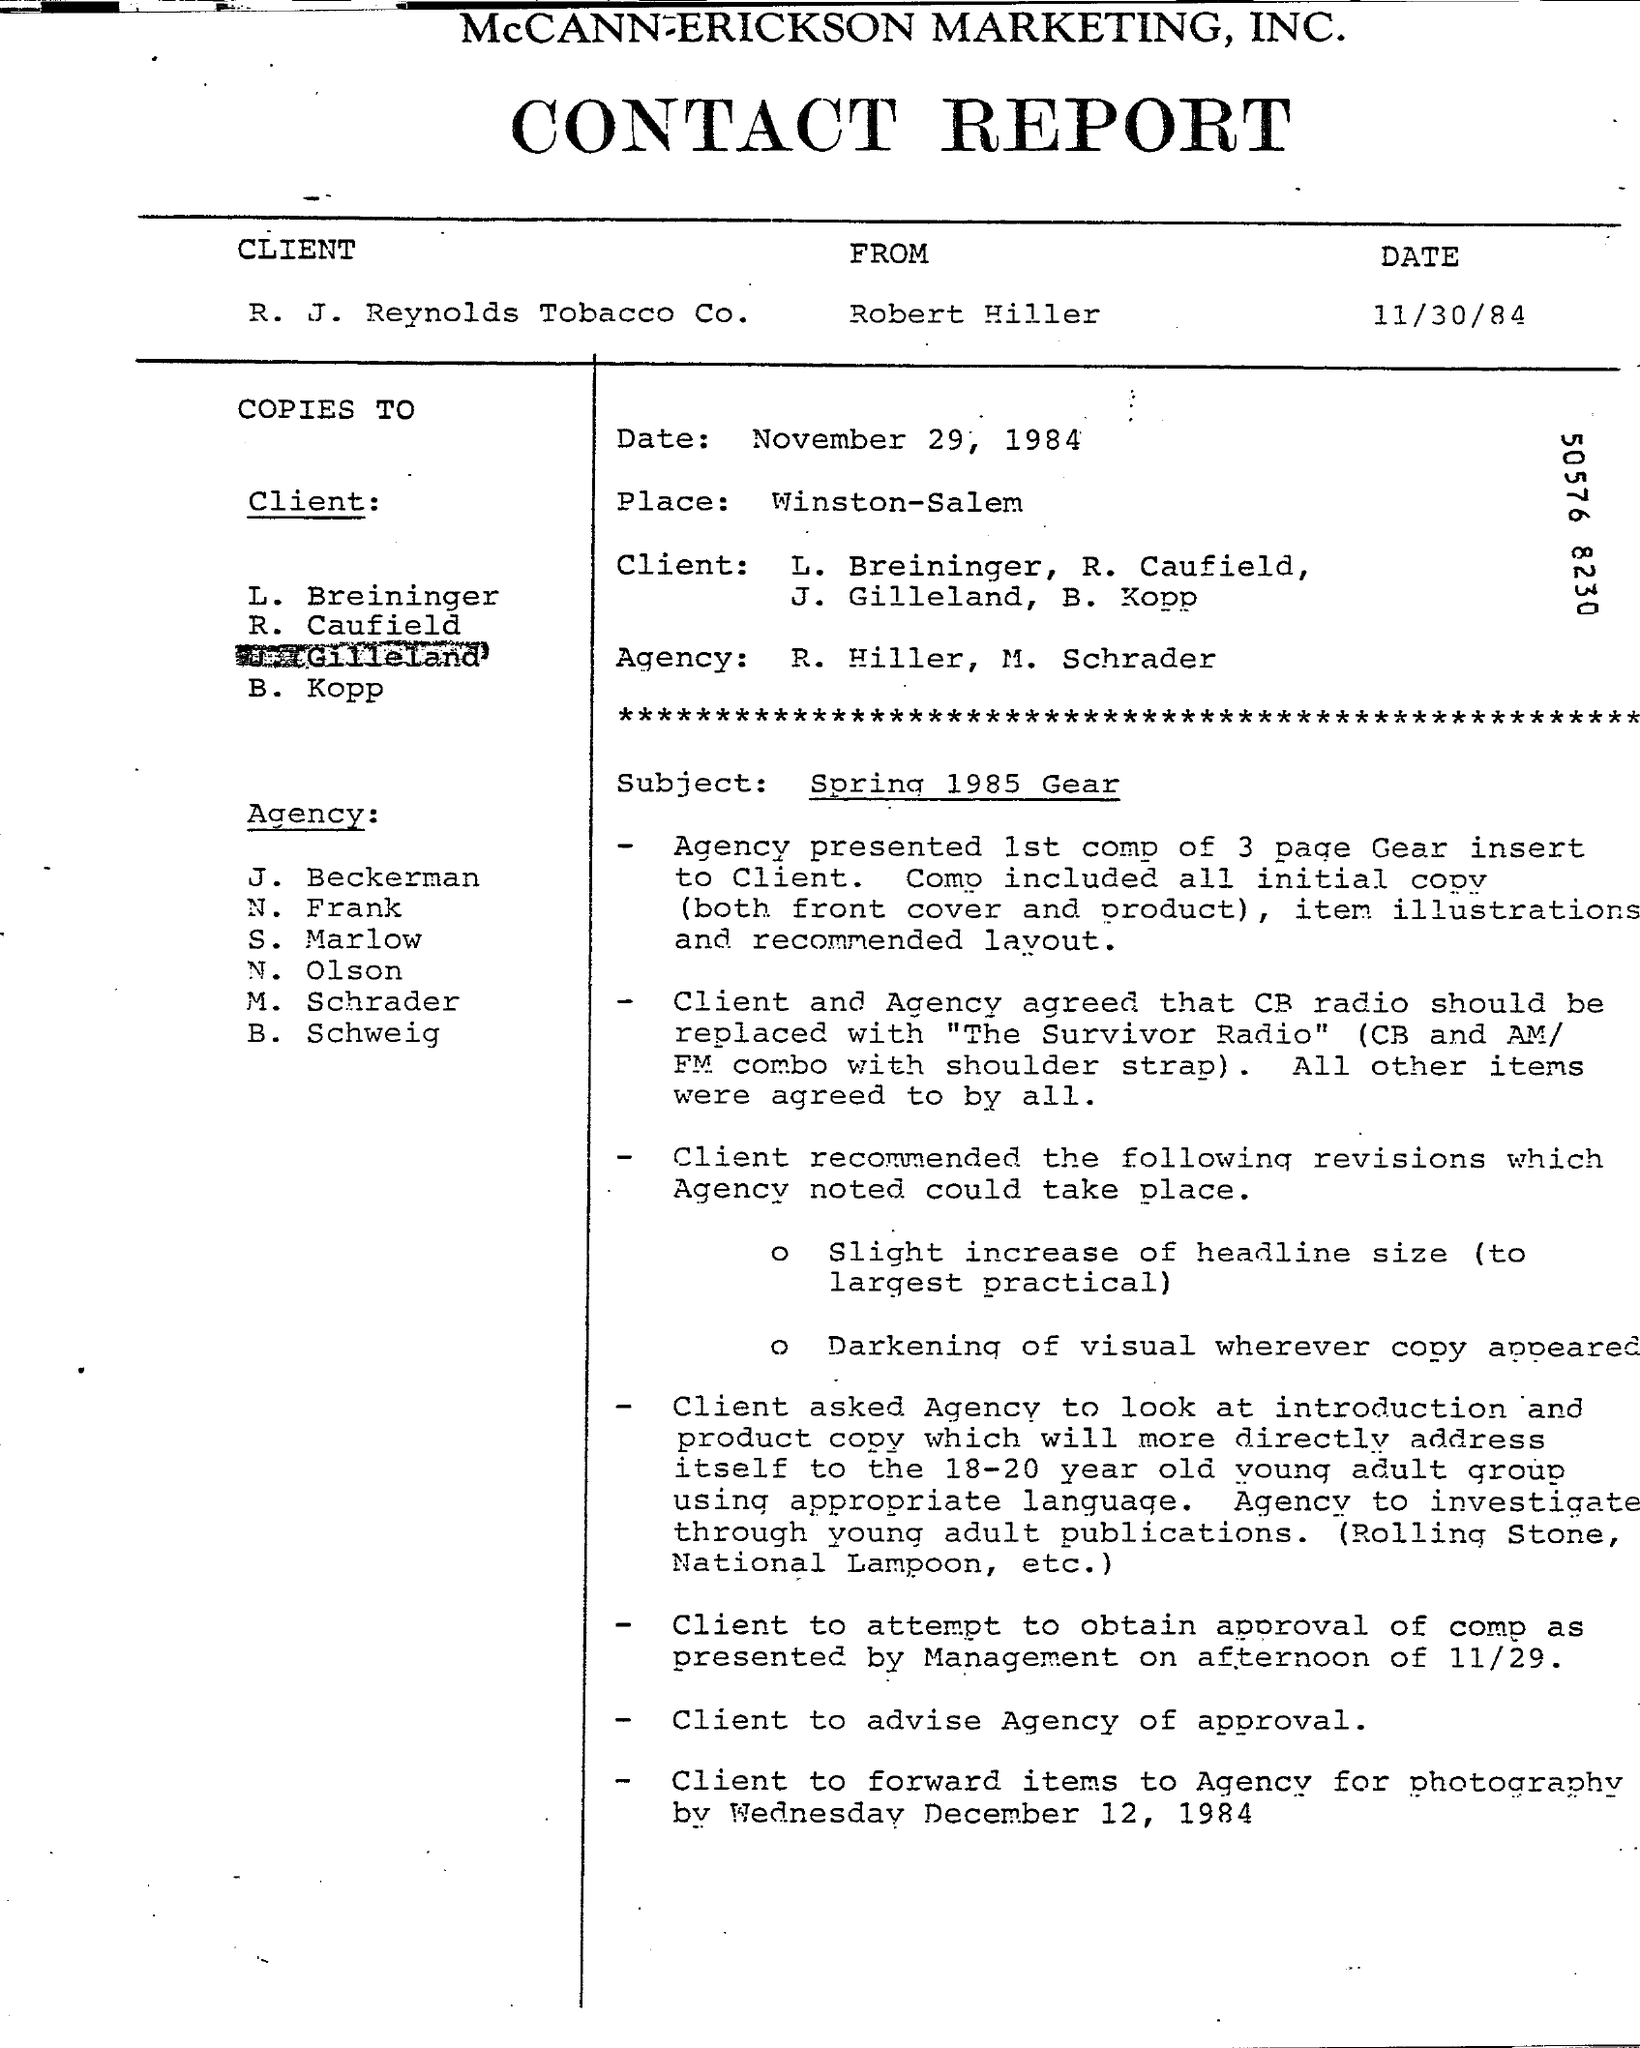What is the heading of the document?
Offer a very short reply. CONTACT REPORT. What is the date mentioned just below the heading?
Keep it short and to the point. 11/30/84. What is the name of the place mentioned?
Offer a very short reply. Winston-Salem. Who is the author of the document?
Provide a succinct answer. Robert Hiller. 